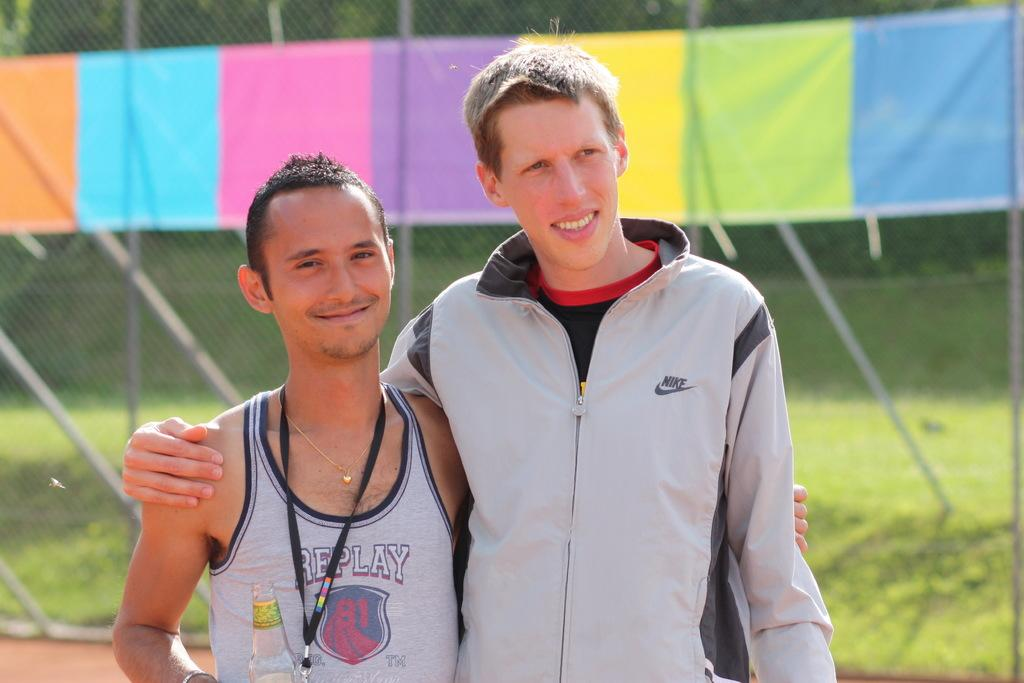<image>
Create a compact narrative representing the image presented. Two guys staning on a running track with the shorter one in a shirt that says replay. 